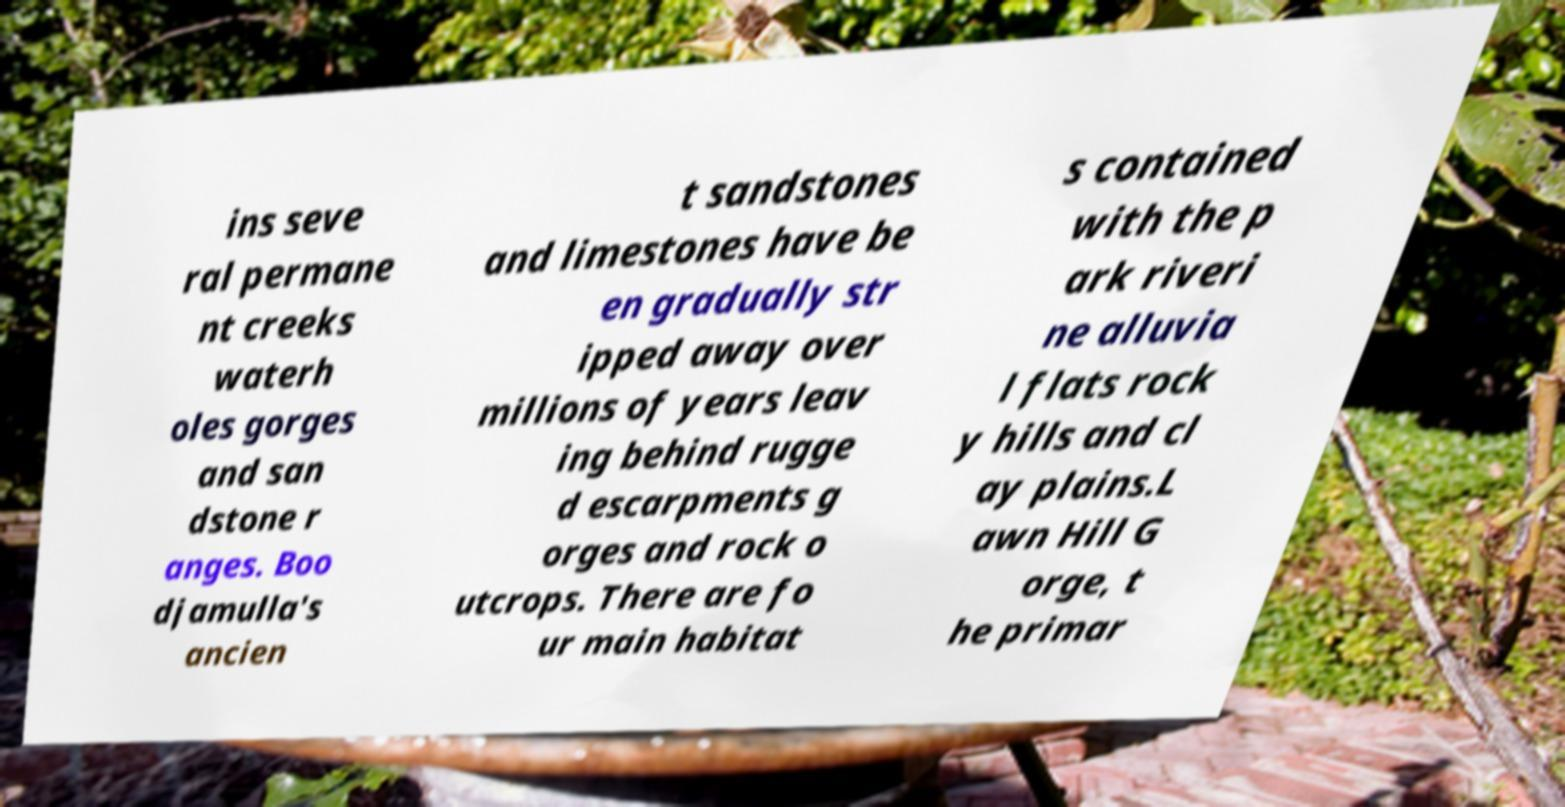There's text embedded in this image that I need extracted. Can you transcribe it verbatim? ins seve ral permane nt creeks waterh oles gorges and san dstone r anges. Boo djamulla's ancien t sandstones and limestones have be en gradually str ipped away over millions of years leav ing behind rugge d escarpments g orges and rock o utcrops. There are fo ur main habitat s contained with the p ark riveri ne alluvia l flats rock y hills and cl ay plains.L awn Hill G orge, t he primar 